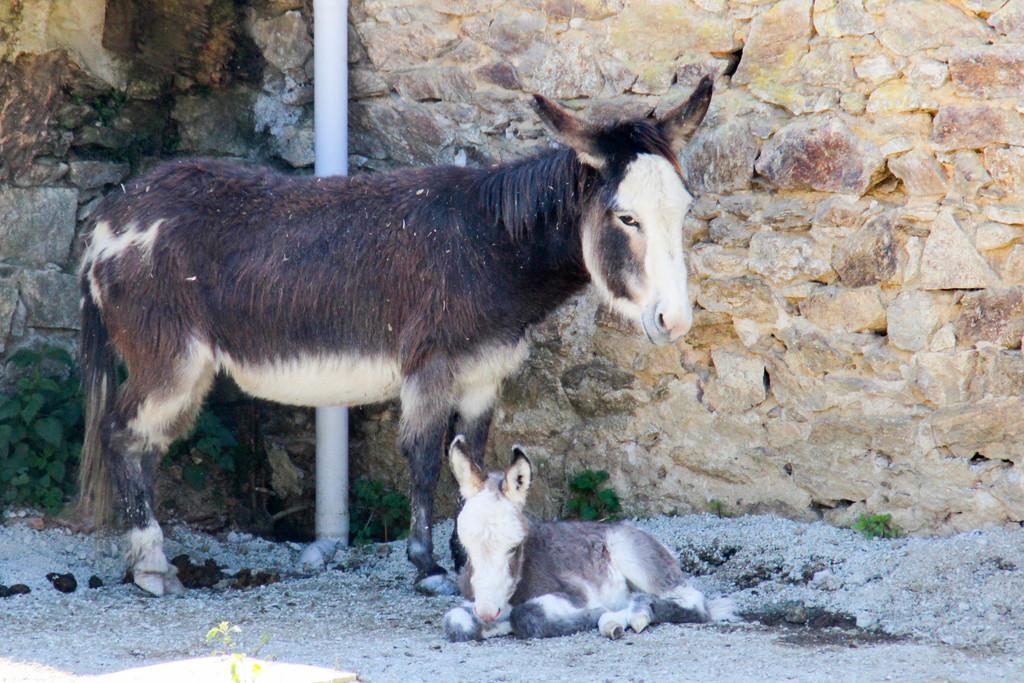What types of living organisms can be seen in the image? There are animals in the image. What can be seen in the background of the image? There is a wall and a rod in the background of the image. What else is present in the image besides the animals and background elements? There are plants in the image. What type of process is being carried out by the crowd in the image? There is no crowd present in the image, so it is not possible to determine what process might be carried out. 